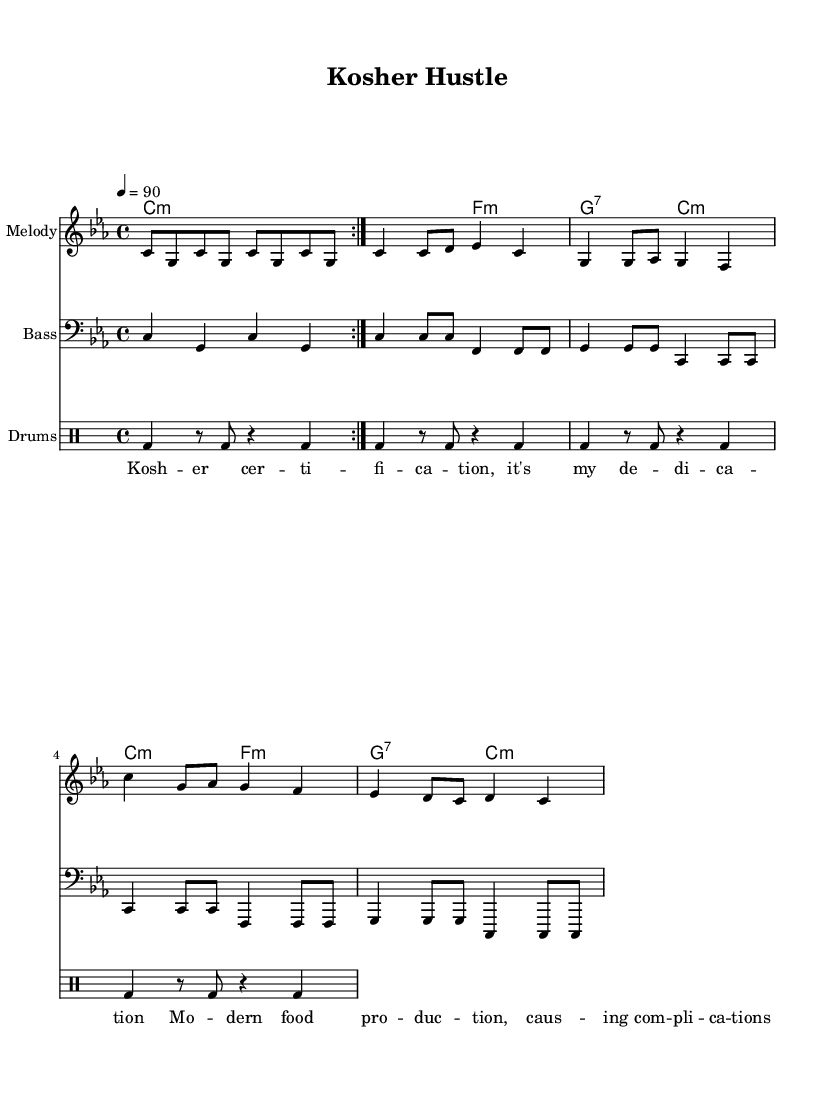What is the key signature of this music? The key signature indicated is C minor, which has three flats. This is identified by looking at the key signature section in the beginning of the sheet music.
Answer: C minor What is the time signature of this piece? The time signature is 4/4, which is represented at the beginning of the score. This indicates that there are four beats in each measure and the quarter note receives one beat.
Answer: 4/4 What is the tempo marking of the music? The tempo marking indicates a speed of 90 beats per minute. This is seen in the tempo section at the top of the sheet music.
Answer: 90 How many measures are in the melody section? By counting the number of measures in the melody part, which are defined by the vertical bar lines, we find there are 8 measures.
Answer: 8 What instrument is the bass line written for? The bass line is written for the bass clef, which is noted at the beginning of the bassline staff indicating it is suited for a bass instrument.
Answer: Bass What is the main theme of the lyrics in the rap? The main theme expressed in the lyrics relates to kosher certification and its challenges in modern food production, as directly stated in the text below the melody.
Answer: Kosher certification How many times is the first melody phrase repeated? The notation indicates that the first phrase of the melody is repeated twice, as indicated by the 'repeat volta 2' direction prior to that section of music.
Answer: 2 